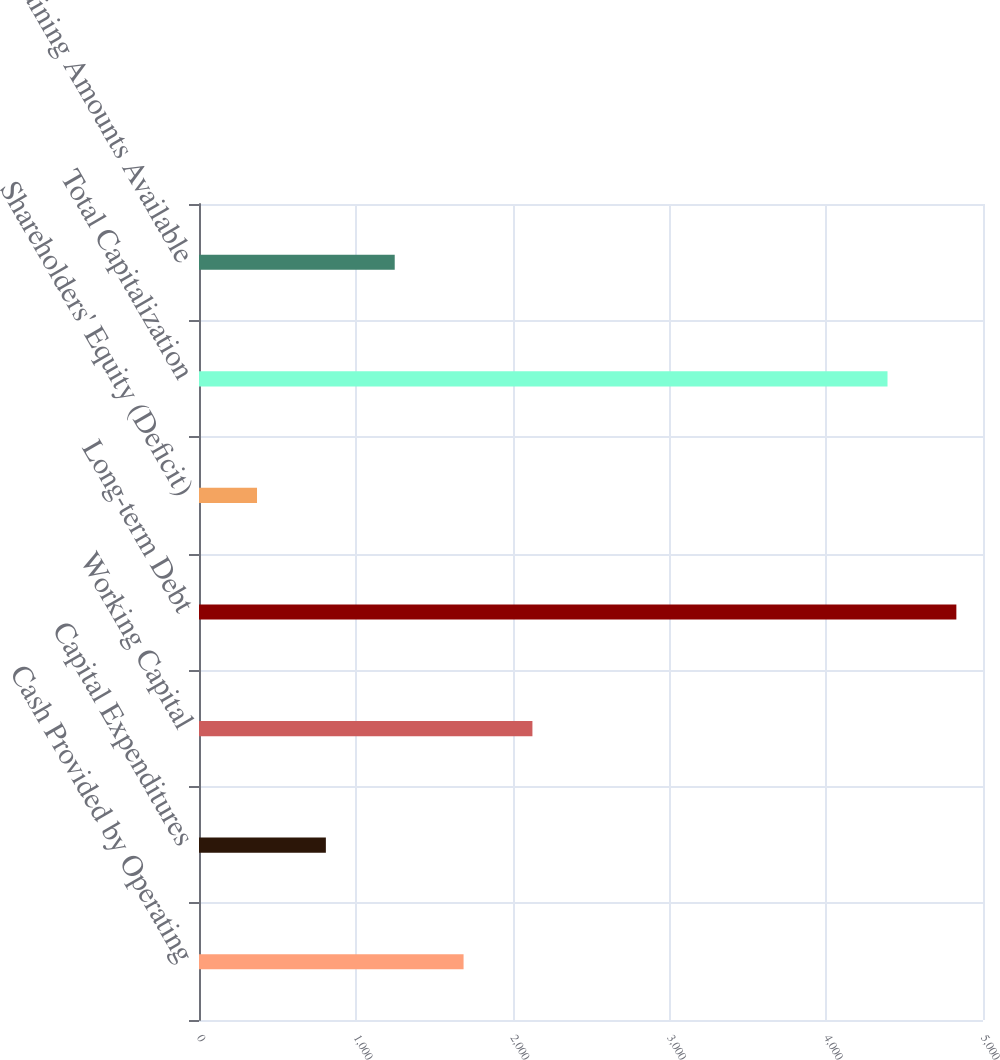Convert chart. <chart><loc_0><loc_0><loc_500><loc_500><bar_chart><fcel>Cash Provided by Operating<fcel>Capital Expenditures<fcel>Working Capital<fcel>Long-term Debt<fcel>Shareholders' Equity (Deficit)<fcel>Total Capitalization<fcel>Remaining Amounts Available<nl><fcel>1687.3<fcel>809.1<fcel>2126.4<fcel>4830.1<fcel>370<fcel>4391<fcel>1248.2<nl></chart> 